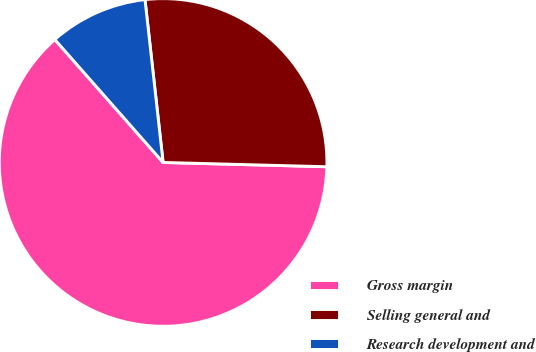Convert chart. <chart><loc_0><loc_0><loc_500><loc_500><pie_chart><fcel>Gross margin<fcel>Selling general and<fcel>Research development and<nl><fcel>63.09%<fcel>27.18%<fcel>9.73%<nl></chart> 